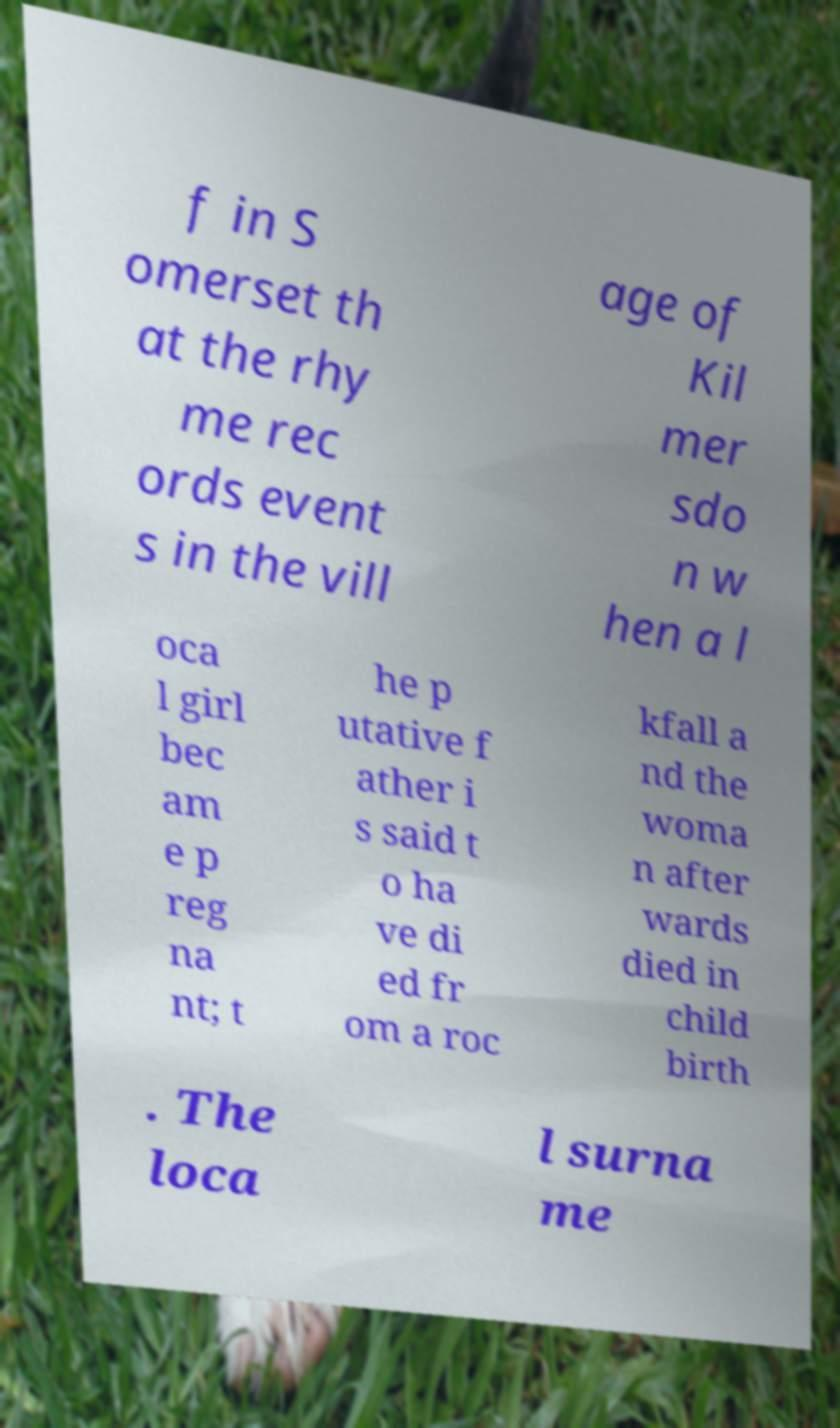Could you assist in decoding the text presented in this image and type it out clearly? f in S omerset th at the rhy me rec ords event s in the vill age of Kil mer sdo n w hen a l oca l girl bec am e p reg na nt; t he p utative f ather i s said t o ha ve di ed fr om a roc kfall a nd the woma n after wards died in child birth . The loca l surna me 